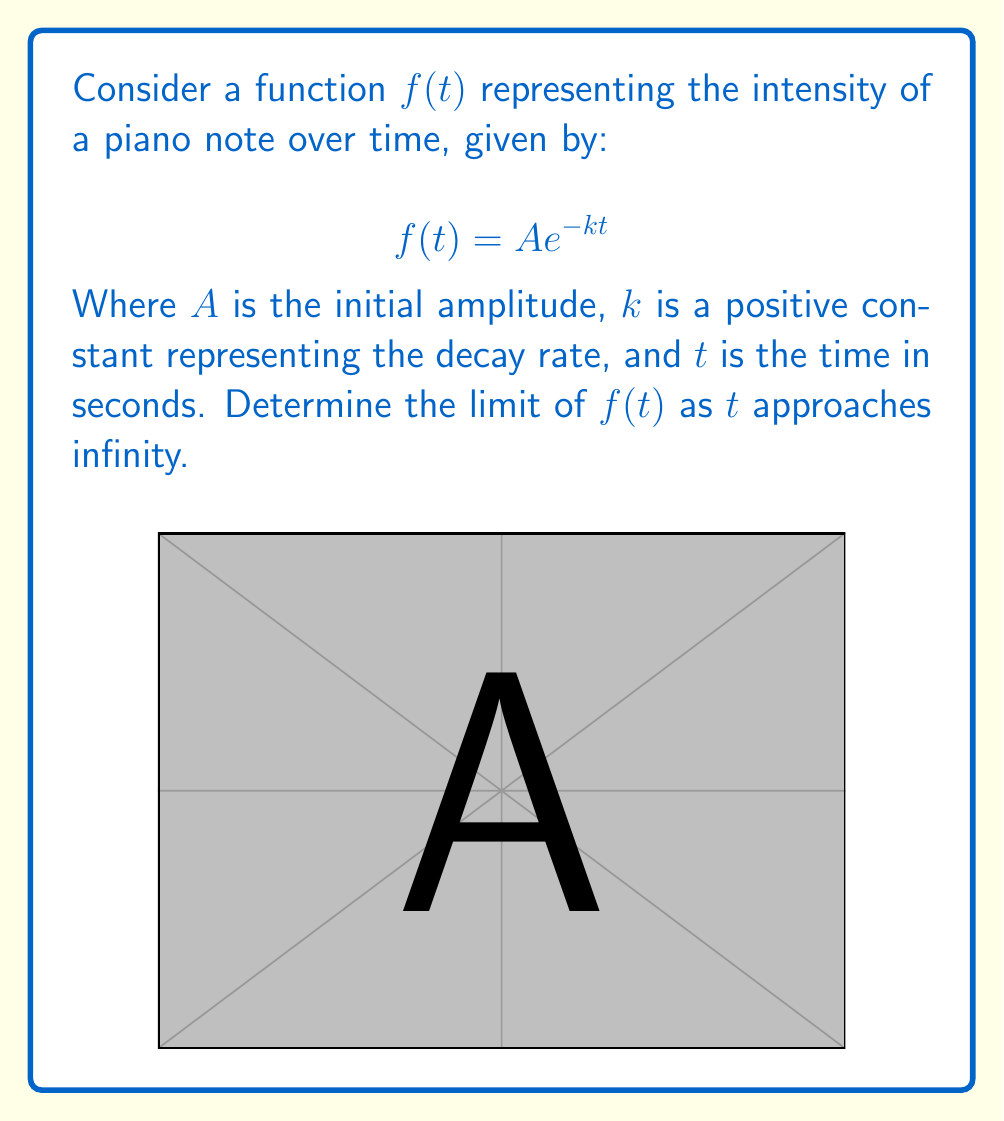What is the answer to this math problem? To determine the limit of $f(t)$ as $t$ approaches infinity, we follow these steps:

1) We start with the given function: $f(t) = A e^{-kt}$

2) We need to evaluate $\lim_{t \to \infty} A e^{-kt}$

3) We can break this down:
   $\lim_{t \to \infty} A e^{-kt} = A \cdot \lim_{t \to \infty} e^{-kt}$

4) Now, let's focus on $\lim_{t \to \infty} e^{-kt}$:
   - $k$ is a positive constant
   - As $t$ approaches infinity, $-kt$ approaches negative infinity
   - $e$ raised to a large negative power approaches zero

5) Therefore, $\lim_{t \to \infty} e^{-kt} = 0$

6) Substituting this back into our original limit:
   $\lim_{t \to \infty} A e^{-kt} = A \cdot 0 = 0$

This result aligns with our intuition about piano notes: as time passes, the intensity of the note gradually diminishes to silence.
Answer: $\lim_{t \to \infty} f(t) = 0$ 